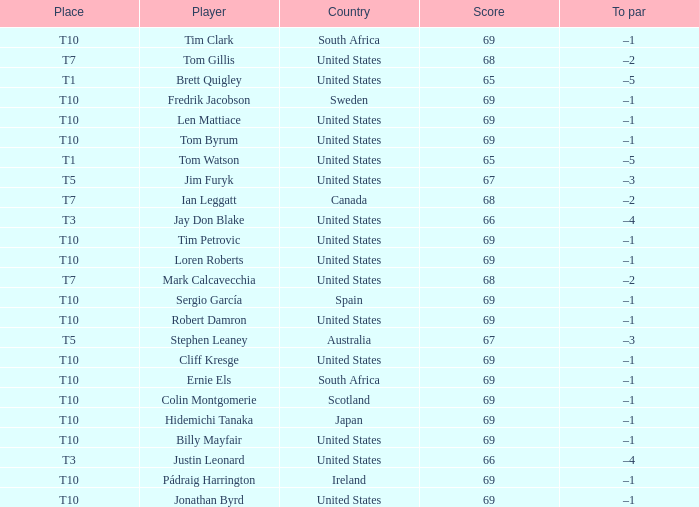What is Tom Gillis' score? 68.0. 